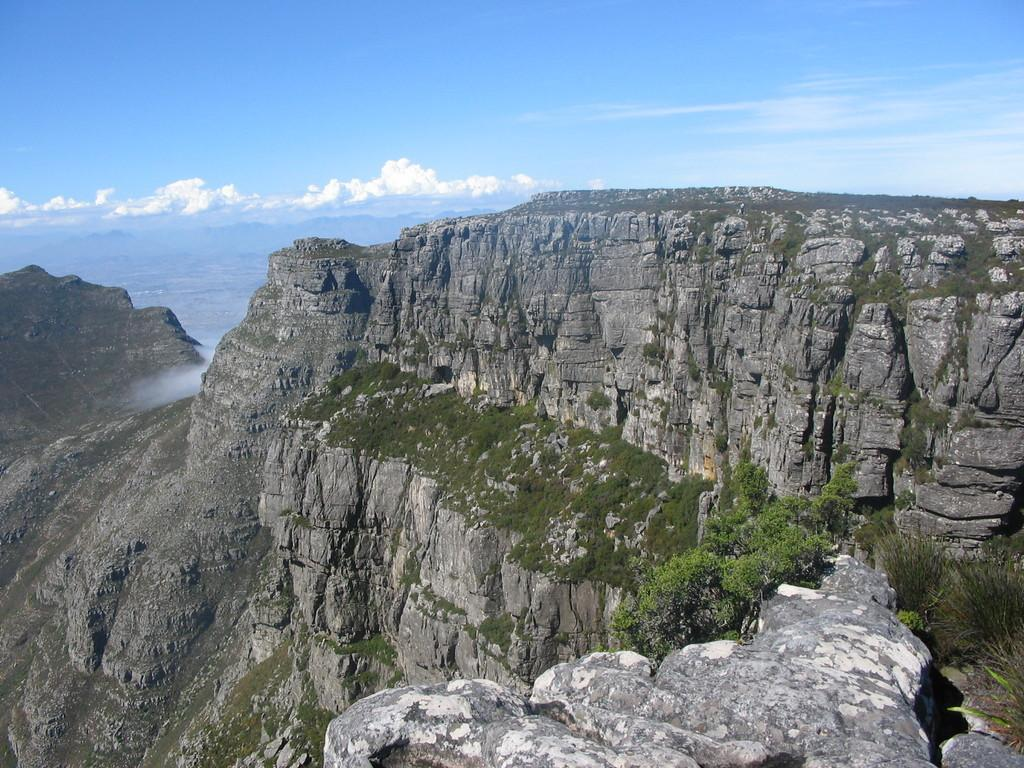What is the main subject of the image? The main subject of the image is a mountain. What can be seen on the mountain? The mountain has grass and plants. What is visible in the background of the image? The sky is visible in the background of the image. What is the condition of the sky in the image? There are clouds in the sky. What type of dog can be seen carrying a basket on the mountain in the image? There is no dog or basket present in the image; it features a mountain with grass and plants, and a cloudy sky. 